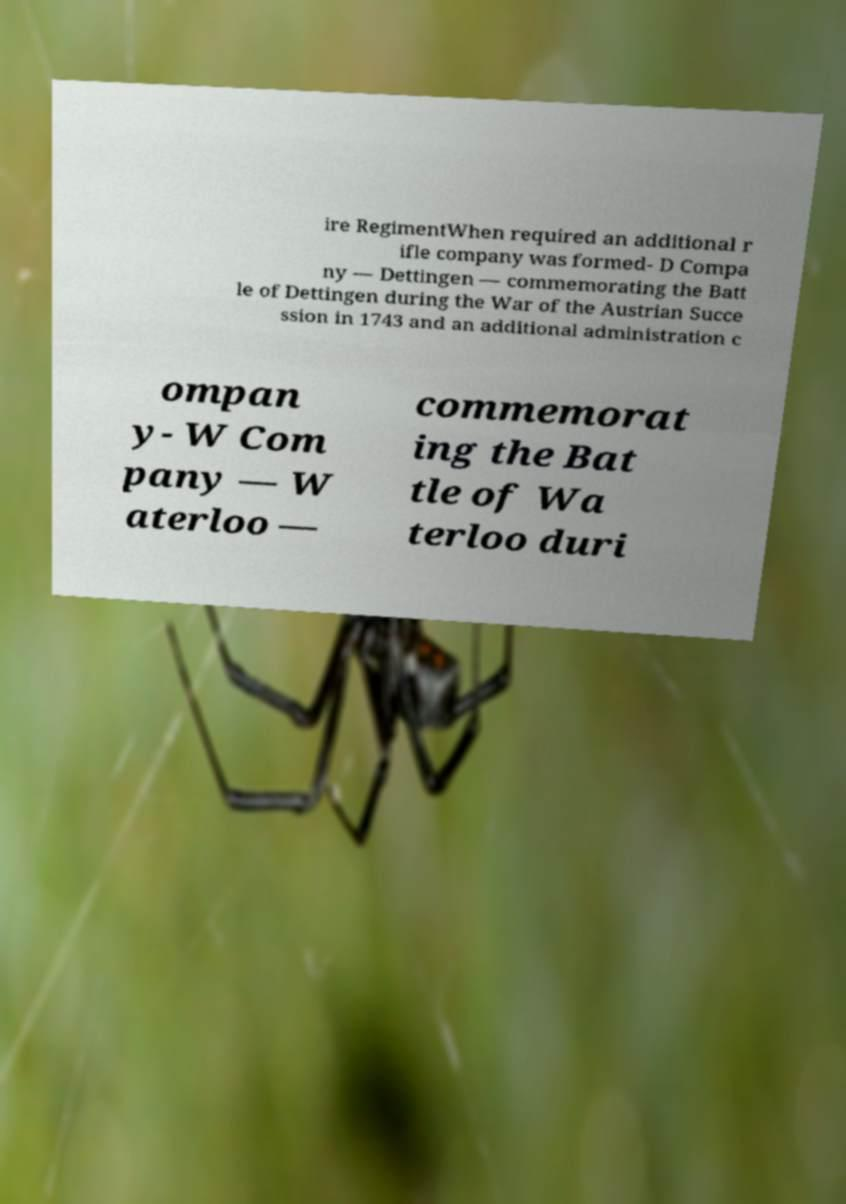Could you extract and type out the text from this image? ire RegimentWhen required an additional r ifle company was formed- D Compa ny — Dettingen — commemorating the Batt le of Dettingen during the War of the Austrian Succe ssion in 1743 and an additional administration c ompan y- W Com pany — W aterloo — commemorat ing the Bat tle of Wa terloo duri 